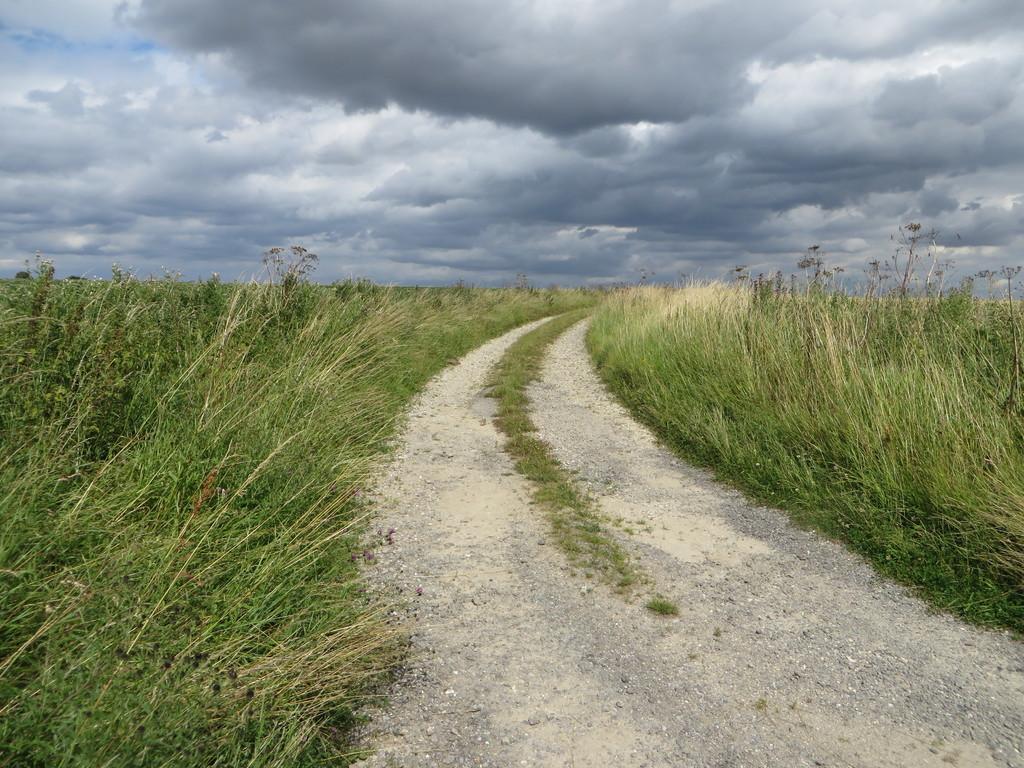Could you give a brief overview of what you see in this image? In this image there is a way in the middle and there's grass on either side of it. At the top there is sky with the clouds. 